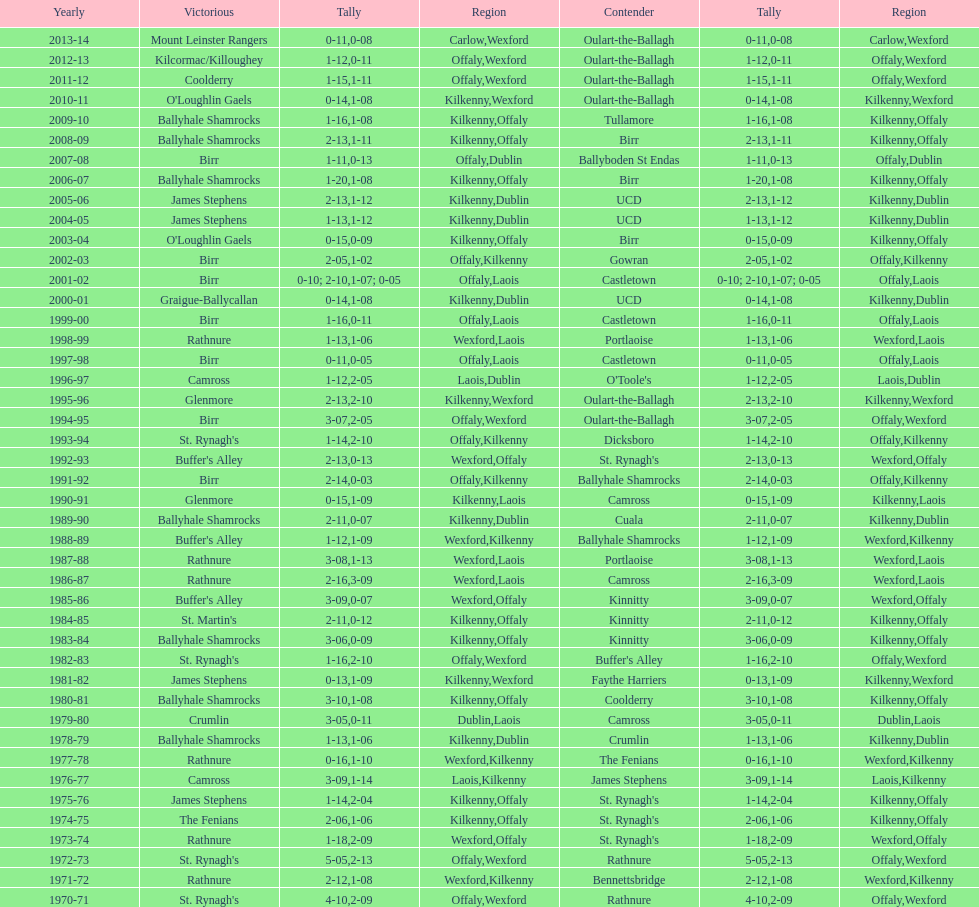Would you be able to parse every entry in this table? {'header': ['Yearly', 'Victorious', 'Tally', 'Region', 'Contender', 'Tally', 'Region'], 'rows': [['2013-14', 'Mount Leinster Rangers', '0-11', 'Carlow', 'Oulart-the-Ballagh', '0-08', 'Wexford'], ['2012-13', 'Kilcormac/Killoughey', '1-12', 'Offaly', 'Oulart-the-Ballagh', '0-11', 'Wexford'], ['2011-12', 'Coolderry', '1-15', 'Offaly', 'Oulart-the-Ballagh', '1-11', 'Wexford'], ['2010-11', "O'Loughlin Gaels", '0-14', 'Kilkenny', 'Oulart-the-Ballagh', '1-08', 'Wexford'], ['2009-10', 'Ballyhale Shamrocks', '1-16', 'Kilkenny', 'Tullamore', '1-08', 'Offaly'], ['2008-09', 'Ballyhale Shamrocks', '2-13', 'Kilkenny', 'Birr', '1-11', 'Offaly'], ['2007-08', 'Birr', '1-11', 'Offaly', 'Ballyboden St Endas', '0-13', 'Dublin'], ['2006-07', 'Ballyhale Shamrocks', '1-20', 'Kilkenny', 'Birr', '1-08', 'Offaly'], ['2005-06', 'James Stephens', '2-13', 'Kilkenny', 'UCD', '1-12', 'Dublin'], ['2004-05', 'James Stephens', '1-13', 'Kilkenny', 'UCD', '1-12', 'Dublin'], ['2003-04', "O'Loughlin Gaels", '0-15', 'Kilkenny', 'Birr', '0-09', 'Offaly'], ['2002-03', 'Birr', '2-05', 'Offaly', 'Gowran', '1-02', 'Kilkenny'], ['2001-02', 'Birr', '0-10; 2-10', 'Offaly', 'Castletown', '1-07; 0-05', 'Laois'], ['2000-01', 'Graigue-Ballycallan', '0-14', 'Kilkenny', 'UCD', '1-08', 'Dublin'], ['1999-00', 'Birr', '1-16', 'Offaly', 'Castletown', '0-11', 'Laois'], ['1998-99', 'Rathnure', '1-13', 'Wexford', 'Portlaoise', '1-06', 'Laois'], ['1997-98', 'Birr', '0-11', 'Offaly', 'Castletown', '0-05', 'Laois'], ['1996-97', 'Camross', '1-12', 'Laois', "O'Toole's", '2-05', 'Dublin'], ['1995-96', 'Glenmore', '2-13', 'Kilkenny', 'Oulart-the-Ballagh', '2-10', 'Wexford'], ['1994-95', 'Birr', '3-07', 'Offaly', 'Oulart-the-Ballagh', '2-05', 'Wexford'], ['1993-94', "St. Rynagh's", '1-14', 'Offaly', 'Dicksboro', '2-10', 'Kilkenny'], ['1992-93', "Buffer's Alley", '2-13', 'Wexford', "St. Rynagh's", '0-13', 'Offaly'], ['1991-92', 'Birr', '2-14', 'Offaly', 'Ballyhale Shamrocks', '0-03', 'Kilkenny'], ['1990-91', 'Glenmore', '0-15', 'Kilkenny', 'Camross', '1-09', 'Laois'], ['1989-90', 'Ballyhale Shamrocks', '2-11', 'Kilkenny', 'Cuala', '0-07', 'Dublin'], ['1988-89', "Buffer's Alley", '1-12', 'Wexford', 'Ballyhale Shamrocks', '1-09', 'Kilkenny'], ['1987-88', 'Rathnure', '3-08', 'Wexford', 'Portlaoise', '1-13', 'Laois'], ['1986-87', 'Rathnure', '2-16', 'Wexford', 'Camross', '3-09', 'Laois'], ['1985-86', "Buffer's Alley", '3-09', 'Wexford', 'Kinnitty', '0-07', 'Offaly'], ['1984-85', "St. Martin's", '2-11', 'Kilkenny', 'Kinnitty', '0-12', 'Offaly'], ['1983-84', 'Ballyhale Shamrocks', '3-06', 'Kilkenny', 'Kinnitty', '0-09', 'Offaly'], ['1982-83', "St. Rynagh's", '1-16', 'Offaly', "Buffer's Alley", '2-10', 'Wexford'], ['1981-82', 'James Stephens', '0-13', 'Kilkenny', 'Faythe Harriers', '1-09', 'Wexford'], ['1980-81', 'Ballyhale Shamrocks', '3-10', 'Kilkenny', 'Coolderry', '1-08', 'Offaly'], ['1979-80', 'Crumlin', '3-05', 'Dublin', 'Camross', '0-11', 'Laois'], ['1978-79', 'Ballyhale Shamrocks', '1-13', 'Kilkenny', 'Crumlin', '1-06', 'Dublin'], ['1977-78', 'Rathnure', '0-16', 'Wexford', 'The Fenians', '1-10', 'Kilkenny'], ['1976-77', 'Camross', '3-09', 'Laois', 'James Stephens', '1-14', 'Kilkenny'], ['1975-76', 'James Stephens', '1-14', 'Kilkenny', "St. Rynagh's", '2-04', 'Offaly'], ['1974-75', 'The Fenians', '2-06', 'Kilkenny', "St. Rynagh's", '1-06', 'Offaly'], ['1973-74', 'Rathnure', '1-18', 'Wexford', "St. Rynagh's", '2-09', 'Offaly'], ['1972-73', "St. Rynagh's", '5-05', 'Offaly', 'Rathnure', '2-13', 'Wexford'], ['1971-72', 'Rathnure', '2-12', 'Wexford', 'Bennettsbridge', '1-08', 'Kilkenny'], ['1970-71', "St. Rynagh's", '4-10', 'Offaly', 'Rathnure', '2-09', 'Wexford']]} What was the last season the leinster senior club hurling championships was won by a score differential of less than 11? 2007-08. 